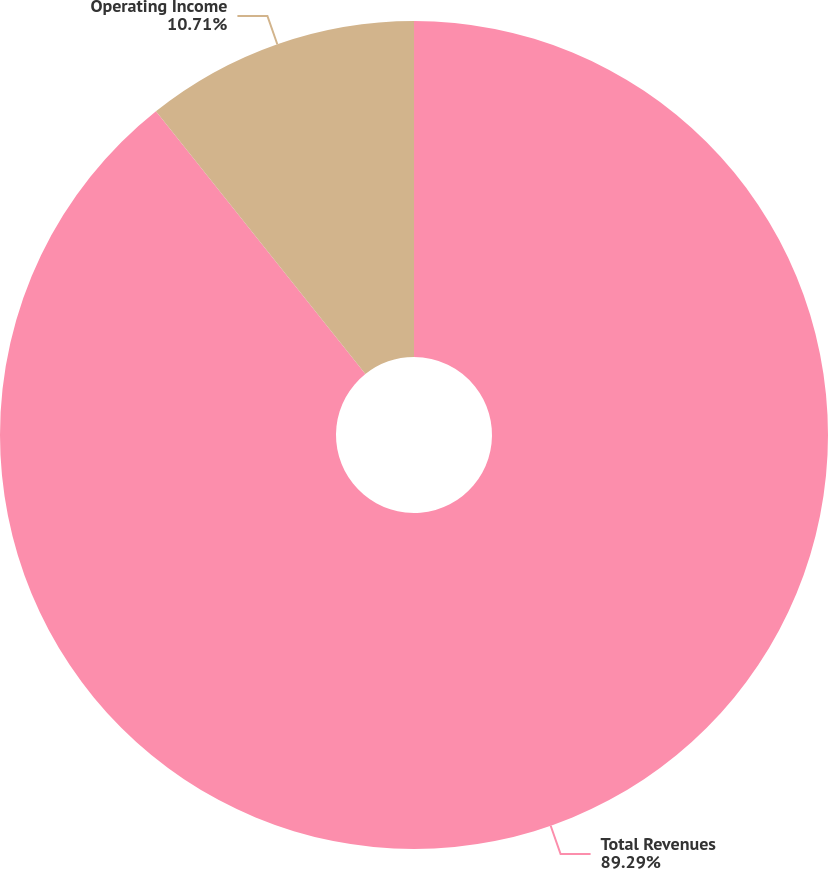<chart> <loc_0><loc_0><loc_500><loc_500><pie_chart><fcel>Total Revenues<fcel>Operating Income<nl><fcel>89.29%<fcel>10.71%<nl></chart> 